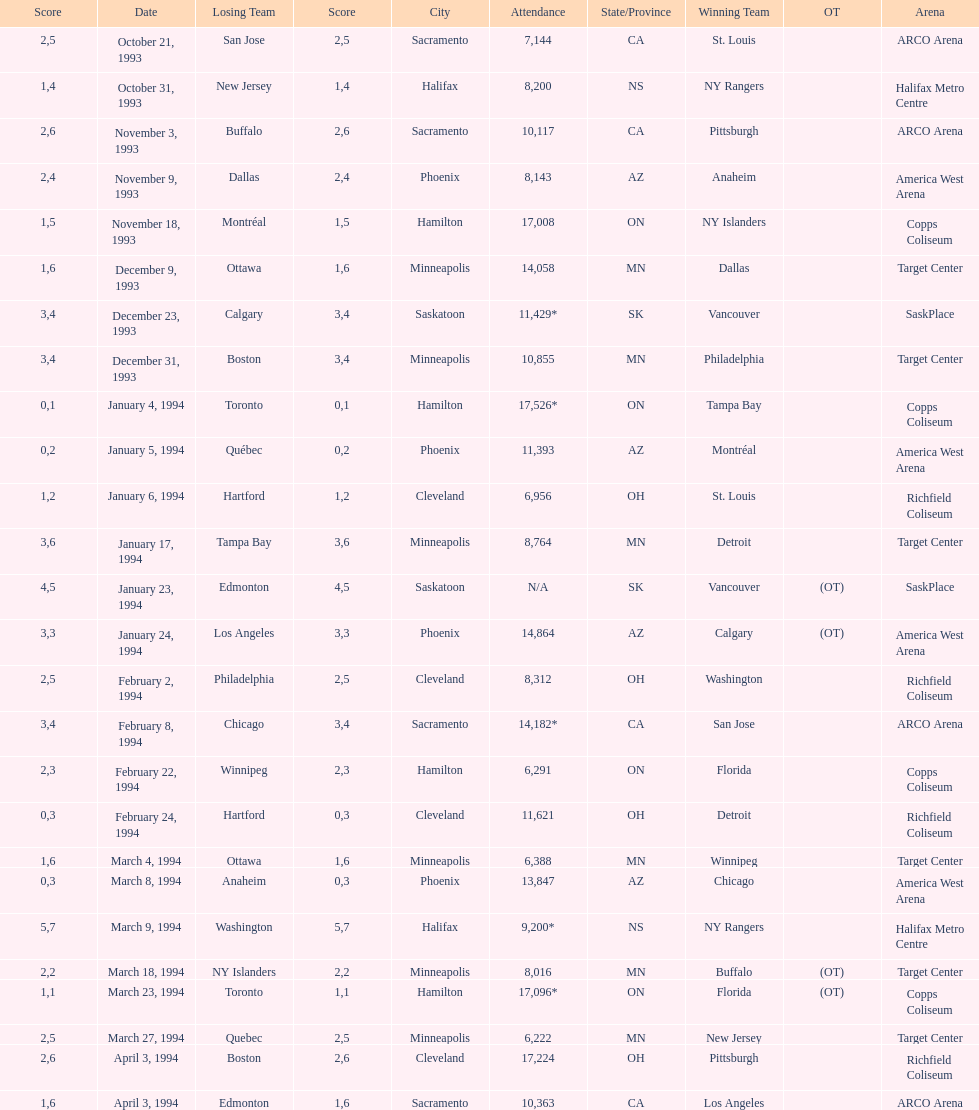Which event had higher attendance, january 24, 1994, or december 23, 1993? January 4, 1994. 